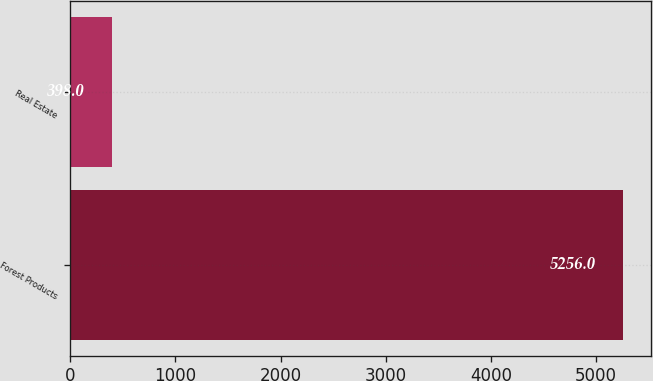Convert chart to OTSL. <chart><loc_0><loc_0><loc_500><loc_500><bar_chart><fcel>Forest Products<fcel>Real Estate<nl><fcel>5256<fcel>398<nl></chart> 